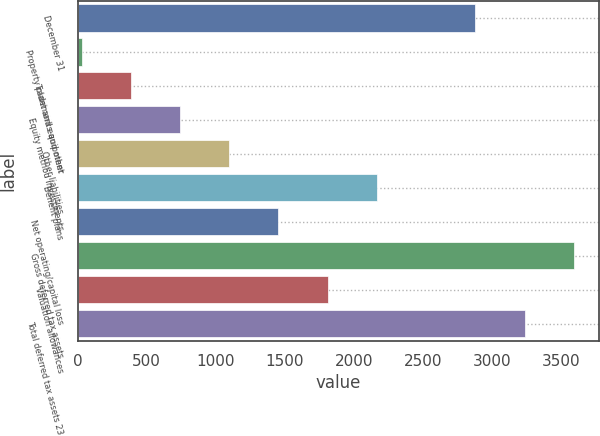<chart> <loc_0><loc_0><loc_500><loc_500><bar_chart><fcel>December 31<fcel>Property plant and equipment<fcel>Trademarks and other<fcel>Equity method investments<fcel>Other liabilities<fcel>Benefit plans<fcel>Net operating/capital loss<fcel>Gross deferred tax assets<fcel>Valuation allowances<fcel>Total deferred tax assets 23<nl><fcel>2881.6<fcel>28<fcel>384.7<fcel>741.4<fcel>1098.1<fcel>2168.2<fcel>1454.8<fcel>3595<fcel>1811.5<fcel>3238.3<nl></chart> 